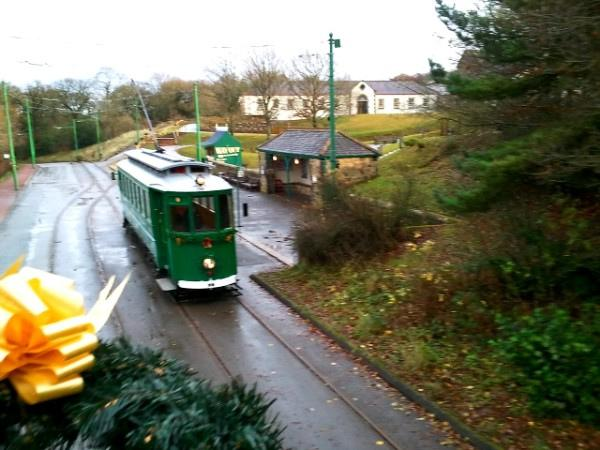What holiday is most likely next?

Choices:
A) christmas
B) thanksgiving
C) halloween
D) easter christmas 